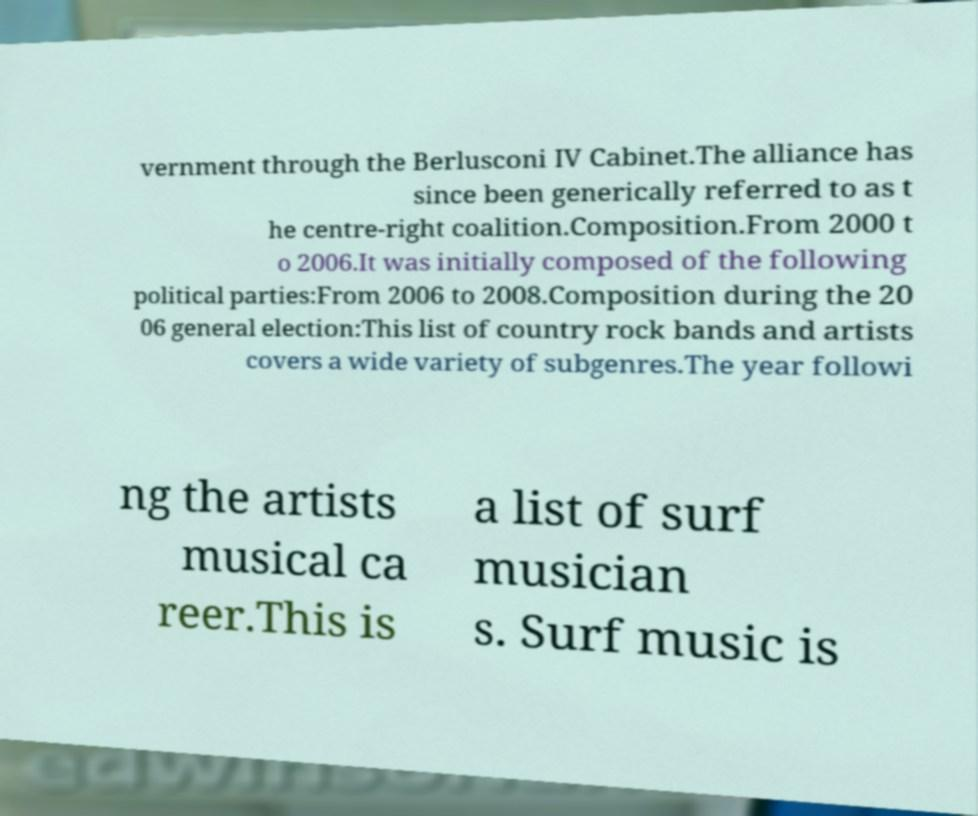For documentation purposes, I need the text within this image transcribed. Could you provide that? vernment through the Berlusconi IV Cabinet.The alliance has since been generically referred to as t he centre-right coalition.Composition.From 2000 t o 2006.It was initially composed of the following political parties:From 2006 to 2008.Composition during the 20 06 general election:This list of country rock bands and artists covers a wide variety of subgenres.The year followi ng the artists musical ca reer.This is a list of surf musician s. Surf music is 